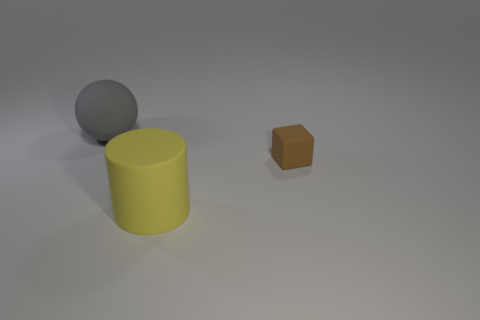The small matte block is what color?
Make the answer very short. Brown. How many things are either matte objects on the right side of the large gray matte object or tiny brown cubes?
Make the answer very short. 2. There is a thing that is on the left side of the yellow cylinder; is its size the same as the brown rubber block that is right of the large yellow thing?
Your response must be concise. No. How many objects are things that are in front of the large sphere or large matte objects that are in front of the large gray matte object?
Offer a very short reply. 2. Are the block and the big thing in front of the gray matte thing made of the same material?
Keep it short and to the point. Yes. There is a rubber object that is behind the rubber cylinder and right of the gray matte ball; what is its shape?
Your response must be concise. Cube. What number of other objects are the same color as the matte cylinder?
Your answer should be compact. 0. What is the shape of the brown matte thing?
Your response must be concise. Cube. What color is the matte thing on the right side of the big matte object right of the big gray ball?
Ensure brevity in your answer.  Brown. Is there another cube of the same size as the rubber block?
Ensure brevity in your answer.  No. 